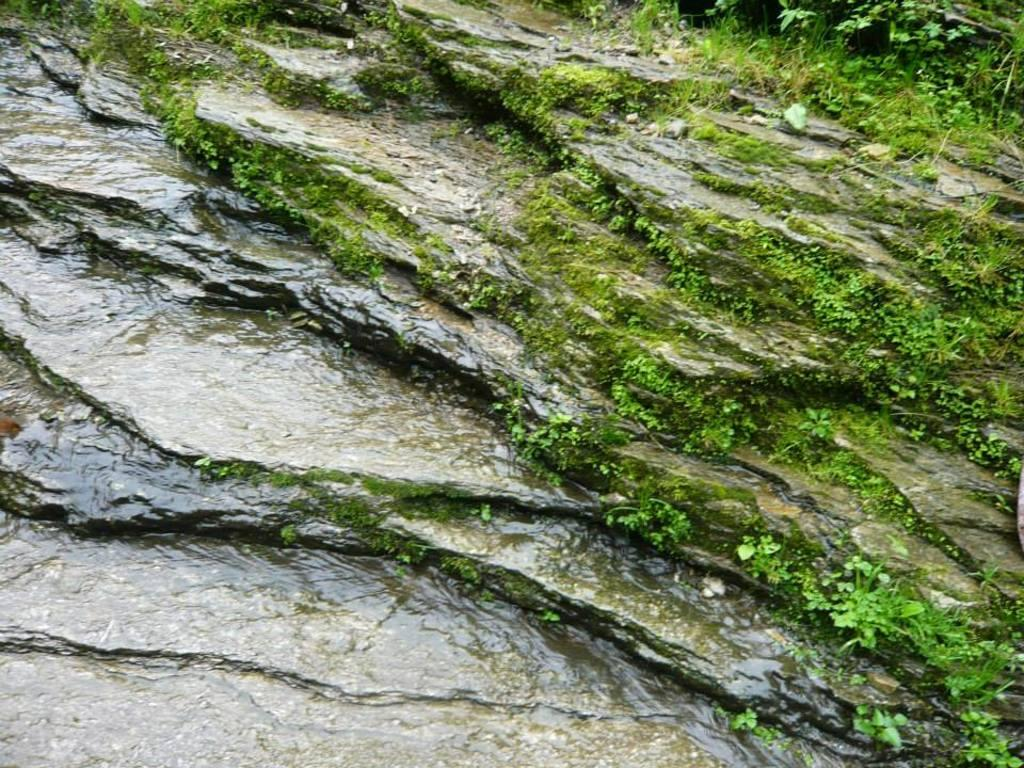What is the main subject of the image? There is a rock in the image. What is located at the bottom of the rock? There is water at the bottom of the rock. What type of vegetation can be seen in the image? There are small plants in the image. What type of grass is visible in the image? There is green grass in the right corner of the image. Can you tell me how many times the rock was kicked in the image? There is no indication in the image that the rock was kicked, so it cannot be determined from the picture. What type of pie is being served on the grass in the image? There is no pie present in the image; it features a rock, water, small plants, and green grass. 